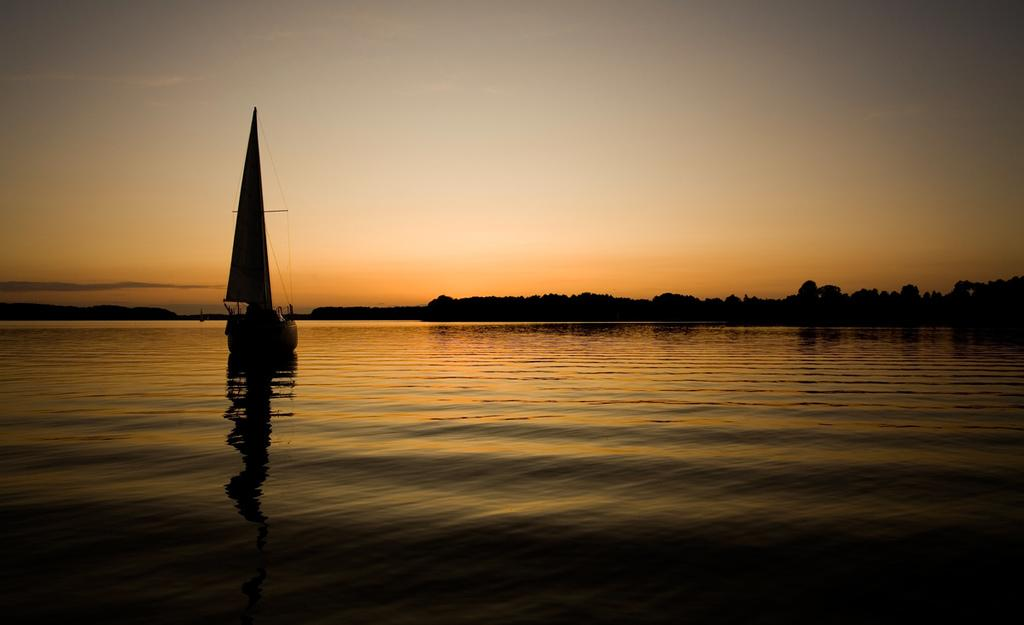What is the main subject of the image? The main subject of the image is a boat. Where is the boat located? The boat is on the water. What can be seen in the background of the image? There are trees, a hill, and the sky visible in the background of the image. Can you tell me how many balls the mother is holding on the scale in the image? There is no mother, balls, or scale present in the image. 